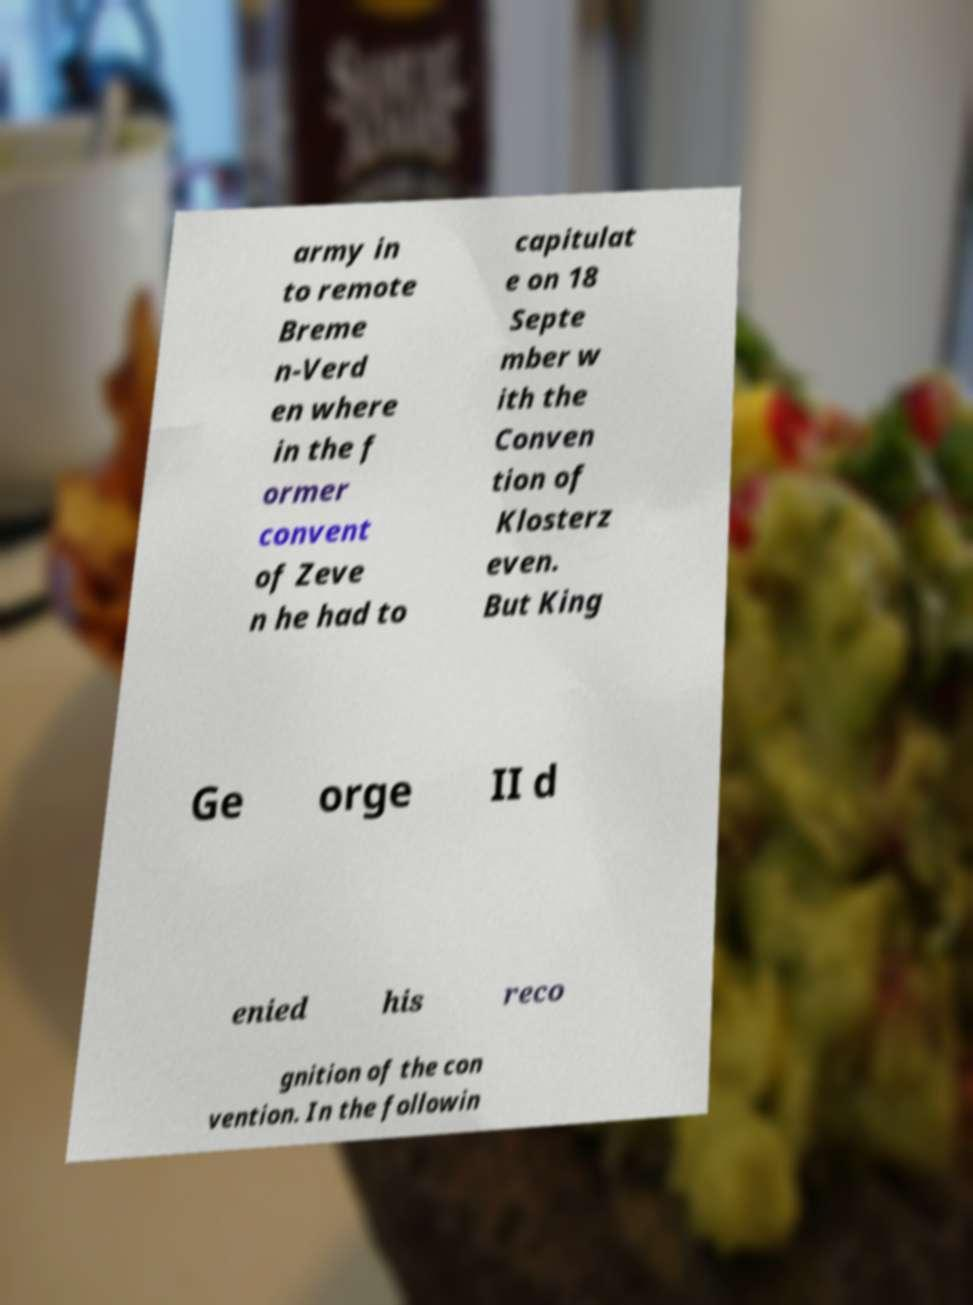Could you assist in decoding the text presented in this image and type it out clearly? army in to remote Breme n-Verd en where in the f ormer convent of Zeve n he had to capitulat e on 18 Septe mber w ith the Conven tion of Klosterz even. But King Ge orge II d enied his reco gnition of the con vention. In the followin 